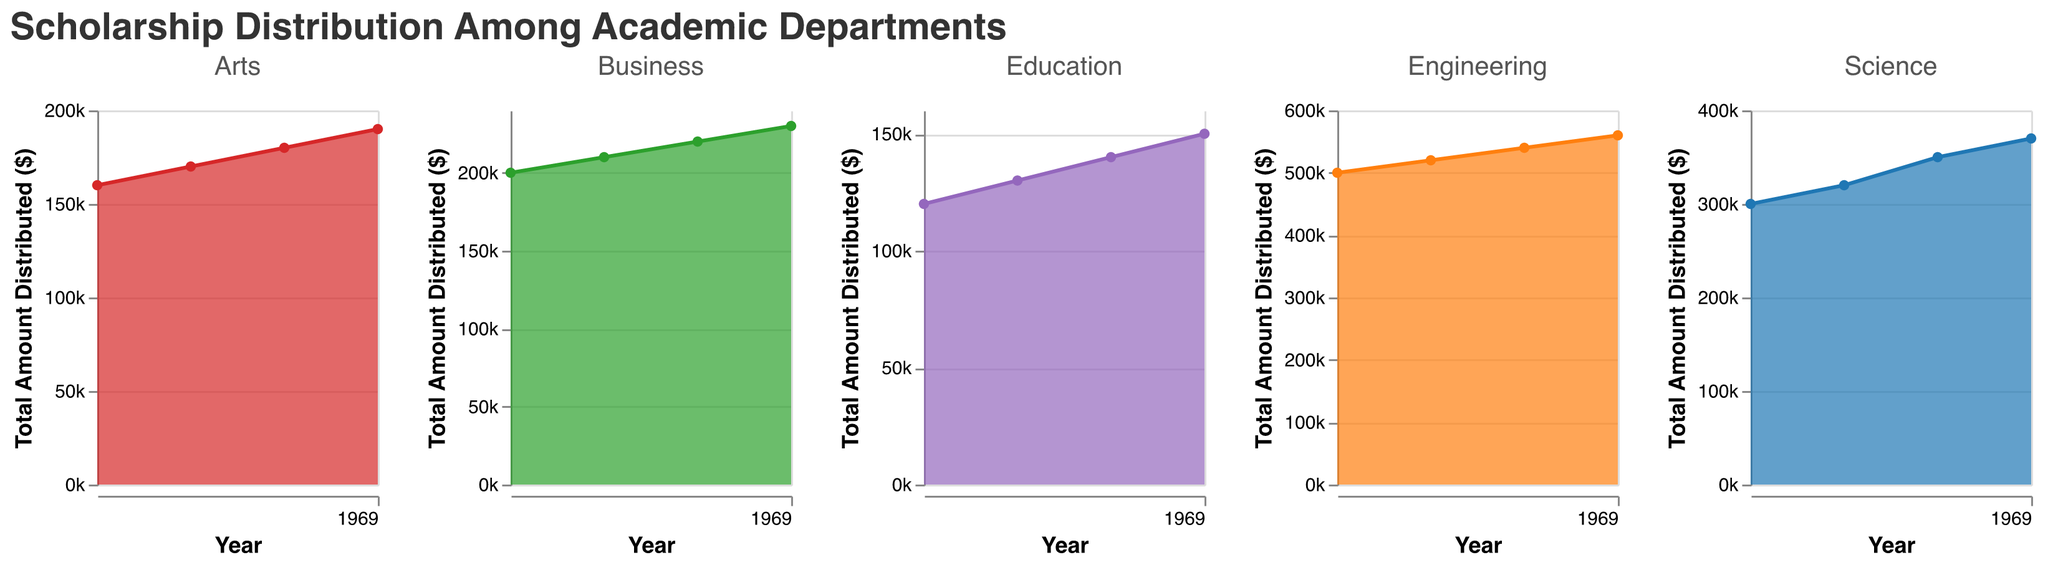How many total scholarships were distributed by all departments in 2020? To find the total scholarships distributed in 2020, sum the number of scholarships given by each department in that year: Science (130) + Engineering (210) + Business (85) + Arts (75) + Education (55) = 555.
Answer: 555 Which department had the highest increase in the total amount distributed between 2019 and 2022? Calculate the difference in total amount distributed for each department from 2019 to 2022: Science (370,000 - 300,000 = 70,000), Engineering (560,000 - 500,000 = 60,000), Business (230,000 - 200,000 = 30,000), Arts (190,000 - 160,000 = 30,000), Education (150,000 - 120,000 = 30,000). Science had the greatest increase.
Answer: Science In which year did the Business department distribute the least amount of scholarship funds? Look at the total amount distributed by the Business department across the years: 2019 ($200,000), 2020 ($210,000), 2021 ($220,000), 2022 ($230,000). The least amount was in 2019.
Answer: 2019 What was the average amount distributed per scholarship by the Arts department in 2021? First, find the total amount distributed by Arts in 2021 ($180,000) and the number of scholarships (80). Calculate the average: $180,000 / 80 = $2,250.
Answer: $2,250 Which department distributed near $500,000 in 2020? Identify the total amount distributed by each department in 2020 and find the one closest to $500,000. Engineering distributed $520,000, which is closest.
Answer: Engineering How did the number of scholarships awarded by the Education department change from 2019 to 2022? Calculate the difference in the number of scholarships from 2019 (50) to 2022 (65). The number increased by 15 scholarships.
Answer: Increased by 15 Which department experienced a steady increase in the total amount distributed from 2019 to 2022? Examine the pattern of the total amount distributed over the years for each department. All departments show a steady increase, but the simplest to verify is Education: 2019 ($120,000), 2020 ($130,000), 2021 ($140,000), 2022 ($150,000).
Answer: Education Compare the total amount distributed by the Science and Business departments in 2021. Which department distributed more? Look at the total amounts distributed by Science ($350,000) and Business ($220,000) in 2021. Science distributed more.
Answer: Science What was the trend in the number of scholarships distributed by the Engineering department from 2019 to 2022? Review the number of scholarships distributed: 2019 (200), 2020 (210), 2021 (220), 2022 (230). The trend is an increasing number of scholarships each year.
Answer: Increasing 